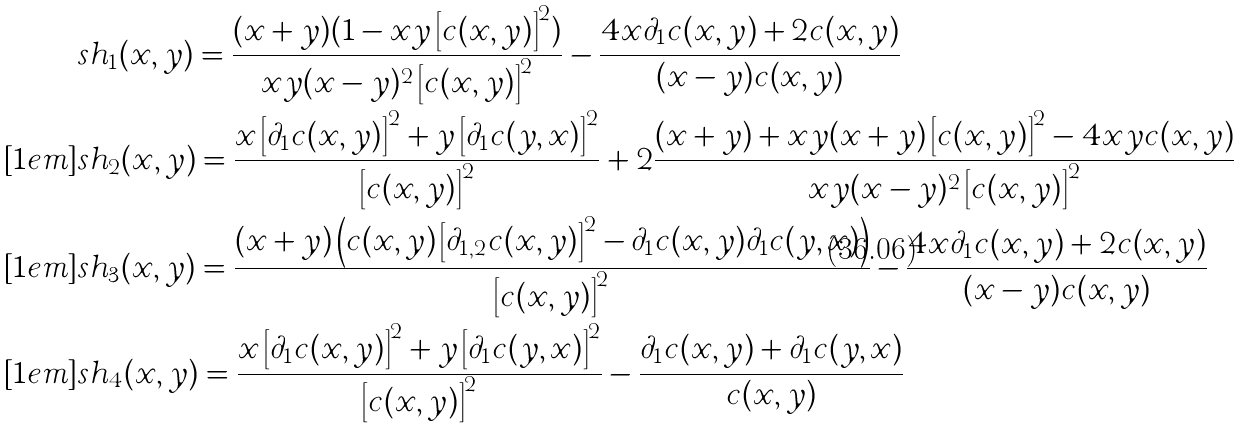Convert formula to latex. <formula><loc_0><loc_0><loc_500><loc_500>& s h _ { 1 } ( x , y ) = \frac { ( x + y ) ( 1 - x y \left [ c ( x , y ) \right ] ^ { 2 } ) } { x y ( x - y ) ^ { 2 } \left [ c ( x , y ) \right ] ^ { 2 } } - \frac { 4 x \partial _ { 1 } c ( x , y ) + 2 c ( x , y ) } { ( x - y ) c ( x , y ) } \\ [ 1 e m ] & s h _ { 2 } ( x , y ) = \frac { x \left [ \partial _ { 1 } c ( x , y ) \right ] ^ { 2 } + y \left [ \partial _ { 1 } c ( y , x ) \right ] ^ { 2 } } { \left [ c ( x , y ) \right ] ^ { 2 } } + 2 \frac { ( x + y ) + x y ( x + y ) \left [ c ( x , y ) \right ] ^ { 2 } - 4 x y c ( x , y ) } { x y ( x - y ) ^ { 2 } \left [ c ( x , y ) \right ] ^ { 2 } } \\ [ 1 e m ] & s h _ { 3 } ( x , y ) = \frac { ( x + y ) \left ( c ( x , y ) \left [ \partial _ { 1 , 2 } c ( x , y ) \right ] ^ { 2 } - \partial _ { 1 } c ( x , y ) \partial _ { 1 } c ( y , x ) \right ) } { \left [ c ( x , y ) \right ] ^ { 2 } } - \frac { 4 x \partial _ { 1 } c ( x , y ) + 2 c ( x , y ) } { ( x - y ) c ( x , y ) } \\ [ 1 e m ] & s h _ { 4 } ( x , y ) = \frac { x \left [ \partial _ { 1 } c ( x , y ) \right ] ^ { 2 } + y \left [ \partial _ { 1 } c ( y , x ) \right ] ^ { 2 } } { \left [ c ( x , y ) \right ] ^ { 2 } } - \frac { \partial _ { 1 } c ( x , y ) + \partial _ { 1 } c ( y , x ) } { c ( x , y ) }</formula> 